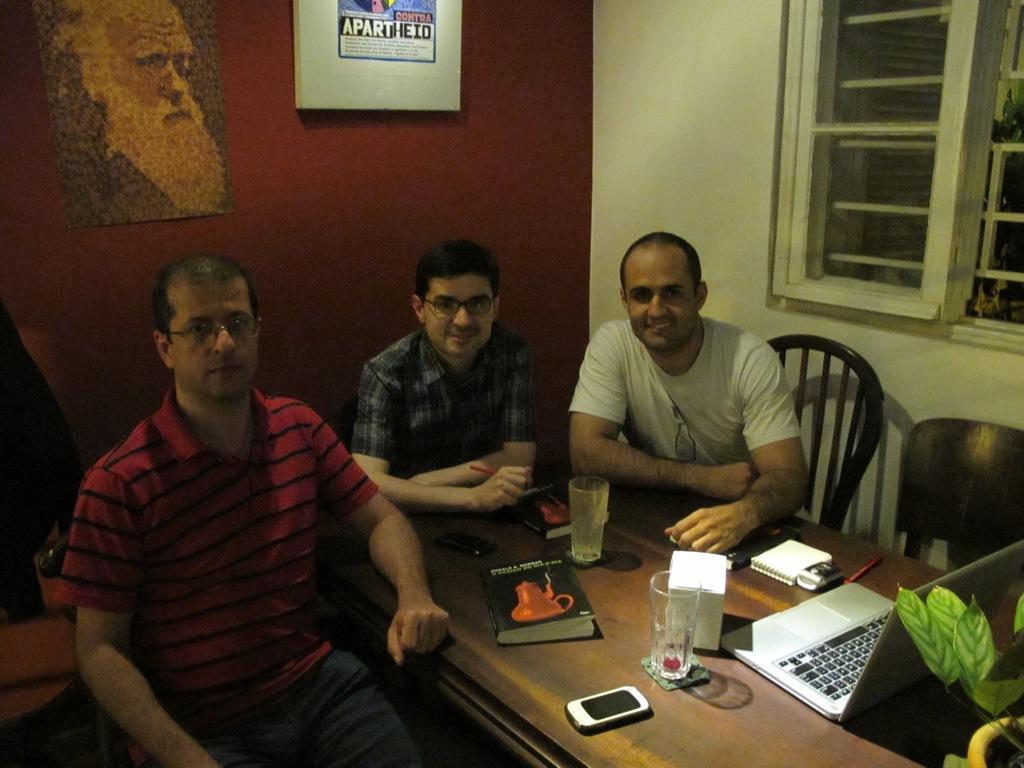How would you summarize this image in a sentence or two? There are three persons sitting in the chairs as we can see in the middle of this image. There is a laptop, glasses and some books and a mobile phone is kept on a table at the bottom of this image. There is a wall in the background. There is a window at the right side of this image. There are two frames attached onto the wall. 